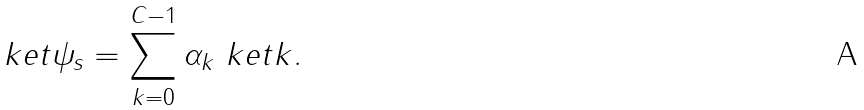Convert formula to latex. <formula><loc_0><loc_0><loc_500><loc_500>\ k e t { \psi _ { s } } = \sum _ { k = 0 } ^ { C - 1 } \alpha _ { k } \ k e t { k } .</formula> 